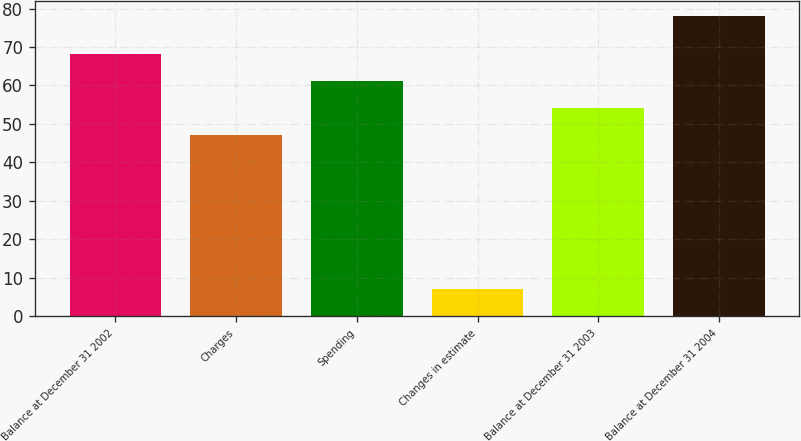<chart> <loc_0><loc_0><loc_500><loc_500><bar_chart><fcel>Balance at December 31 2002<fcel>Charges<fcel>Spending<fcel>Changes in estimate<fcel>Balance at December 31 2003<fcel>Balance at December 31 2004<nl><fcel>68.3<fcel>47<fcel>61.2<fcel>7<fcel>54.1<fcel>78<nl></chart> 